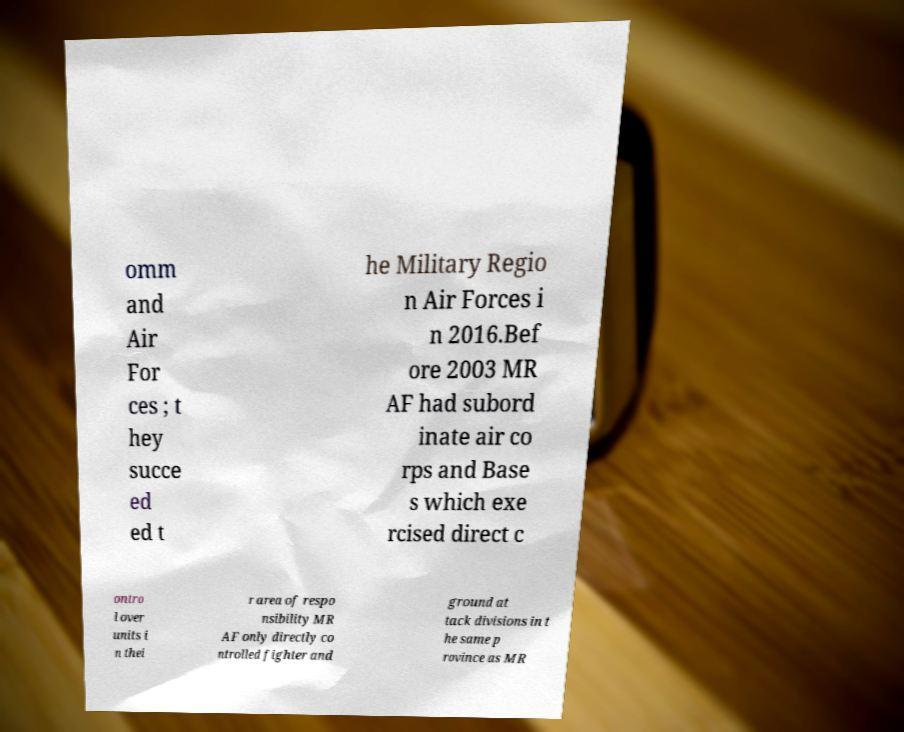For documentation purposes, I need the text within this image transcribed. Could you provide that? omm and Air For ces ; t hey succe ed ed t he Military Regio n Air Forces i n 2016.Bef ore 2003 MR AF had subord inate air co rps and Base s which exe rcised direct c ontro l over units i n thei r area of respo nsibility MR AF only directly co ntrolled fighter and ground at tack divisions in t he same p rovince as MR 